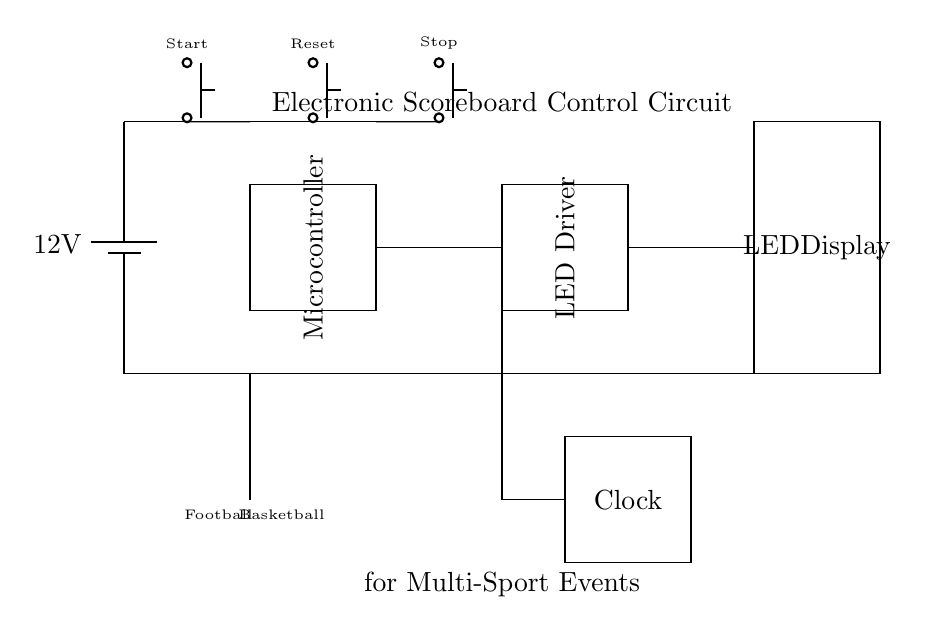What is the voltage of this circuit? The circuit is powered by a battery labeled as 12V, indicating that the voltage supply for the entire circuit is 12 volts.
Answer: 12 volts What component is used to control the scoreboard? The main component responsible for controlling the scoreboard is the microcontroller, which is depicted as a rectangle in the diagram labeled “Microcontroller”.
Answer: Microcontroller How many push buttons are present in this circuit? By counting the push buttons shown in the diagram, there are three push buttons labeled as Start, Reset, and Stop.
Answer: Three What is the purpose of the SPDT switch in this circuit? The SPDT (Single Pole Double Throw) switch serves as a sport selector, which allows the user to toggle between the options of Football and Basketball, as indicated below the switch.
Answer: Sport selector What is connected to the LED driver in this circuit? The LED driver is connected to the LED display, as shown by the line connecting them in the diagram. The LED driver controls the LED display functionality.
Answer: LED display What role does the clock module play in this scoreboard? The clock module provides timekeeping functionality necessary for timing in games, which is essential in scoreboard operation, as indicated by its connection to the microcontroller.
Answer: Timing What is the relationship between the microcontroller and the LED display? The microcontroller processes signals and sends the display data to the LED display through the LED driver, indicating the score or game status to the audience.
Answer: Data control 